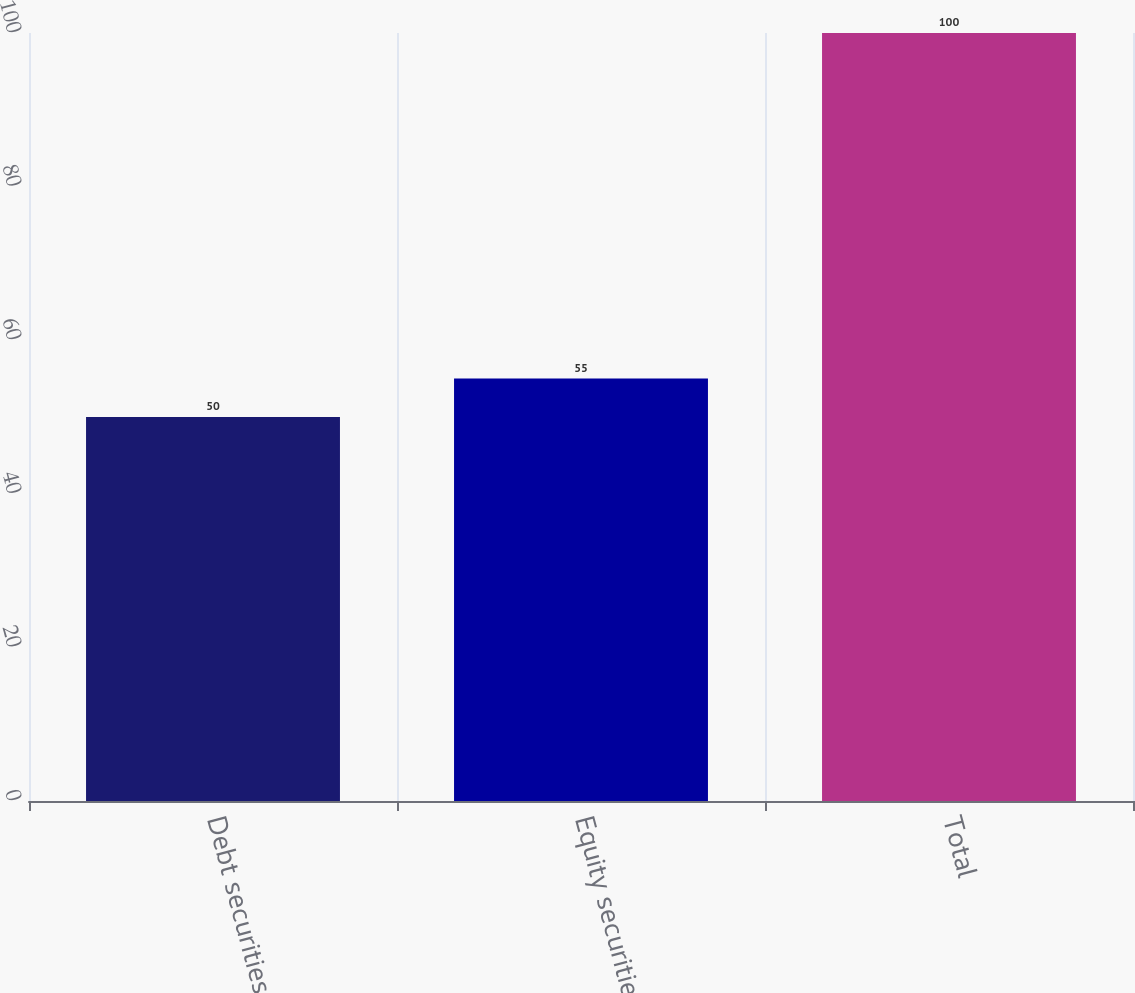Convert chart. <chart><loc_0><loc_0><loc_500><loc_500><bar_chart><fcel>Debt securities (a)<fcel>Equity securities<fcel>Total<nl><fcel>50<fcel>55<fcel>100<nl></chart> 